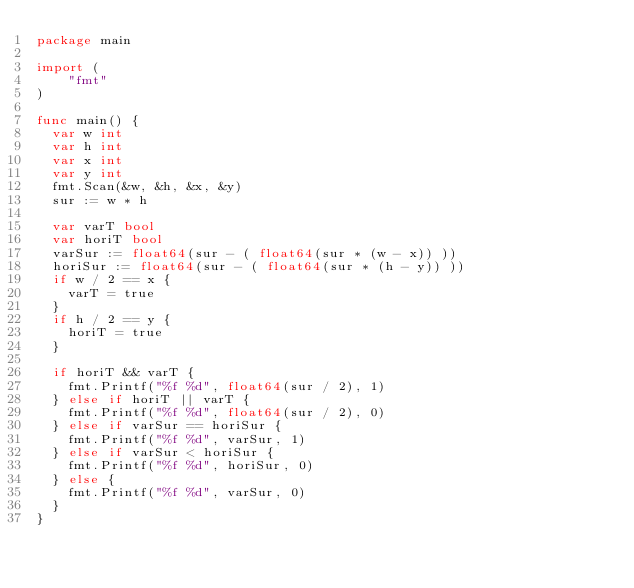<code> <loc_0><loc_0><loc_500><loc_500><_Go_>package main

import (
	"fmt"
)

func main() {
  var w int
  var h int
  var x int
  var y int
  fmt.Scan(&w, &h, &x, &y)
  sur := w * h
  
  var varT bool
  var horiT bool
  varSur := float64(sur - ( float64(sur * (w - x)) ))
  horiSur := float64(sur - ( float64(sur * (h - y)) ))
  if w / 2 == x {
    varT = true
  }
  if h / 2 == y {
    horiT = true
  }
  
  if horiT && varT {
    fmt.Printf("%f %d", float64(sur / 2), 1)
  } else if horiT || varT {
    fmt.Printf("%f %d", float64(sur / 2), 0)
  } else if varSur == horiSur {
    fmt.Printf("%f %d", varSur, 1)
  } else if varSur < horiSur {
    fmt.Printf("%f %d", horiSur, 0)
  } else {
    fmt.Printf("%f %d", varSur, 0)
  }
}</code> 